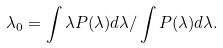<formula> <loc_0><loc_0><loc_500><loc_500>\lambda _ { 0 } = \int \lambda P ( \lambda ) d \lambda / \int P ( \lambda ) d \lambda .</formula> 